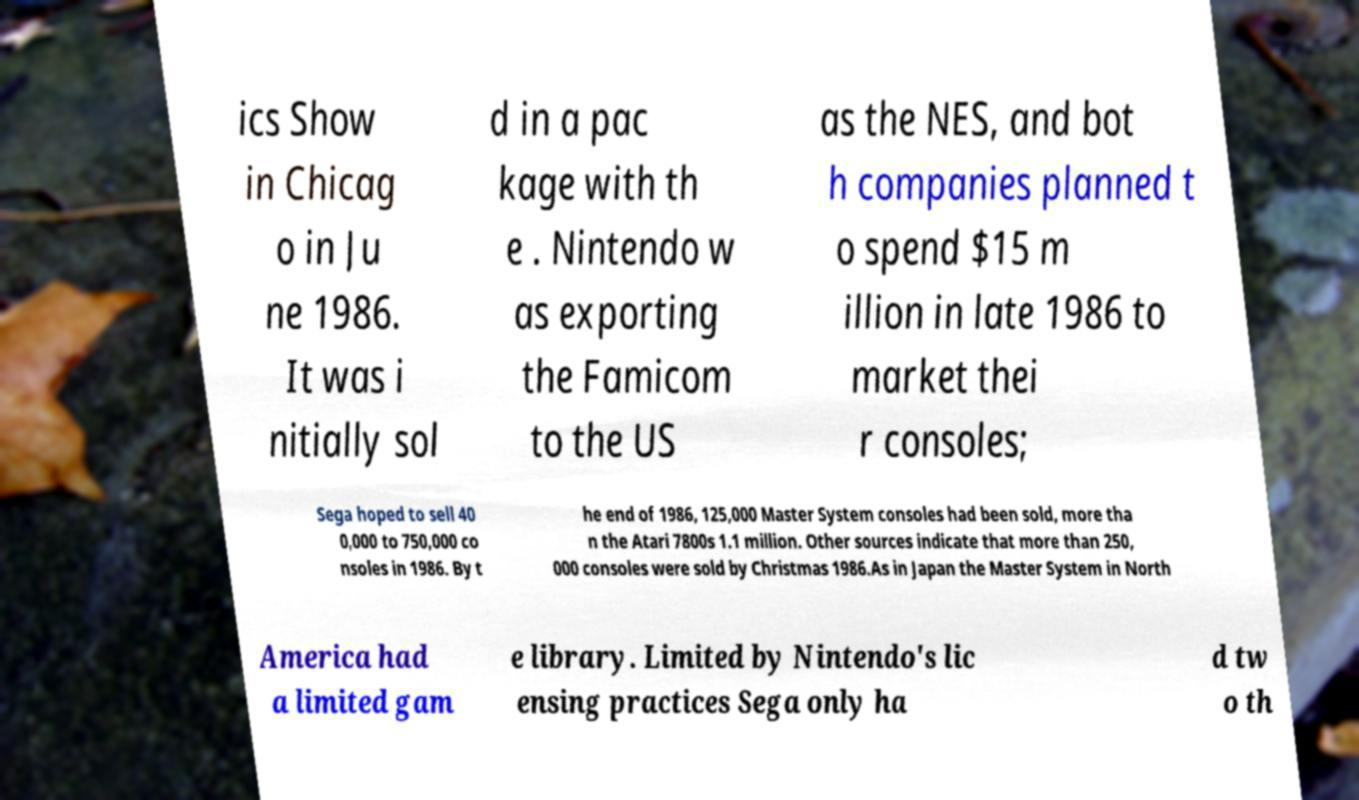Could you assist in decoding the text presented in this image and type it out clearly? ics Show in Chicag o in Ju ne 1986. It was i nitially sol d in a pac kage with th e . Nintendo w as exporting the Famicom to the US as the NES, and bot h companies planned t o spend $15 m illion in late 1986 to market thei r consoles; Sega hoped to sell 40 0,000 to 750,000 co nsoles in 1986. By t he end of 1986, 125,000 Master System consoles had been sold, more tha n the Atari 7800s 1.1 million. Other sources indicate that more than 250, 000 consoles were sold by Christmas 1986.As in Japan the Master System in North America had a limited gam e library. Limited by Nintendo's lic ensing practices Sega only ha d tw o th 